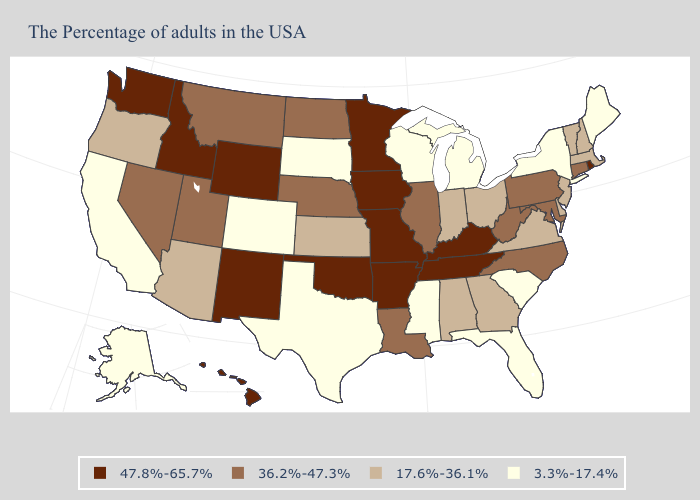Does Wisconsin have the lowest value in the USA?
Write a very short answer. Yes. What is the lowest value in states that border South Carolina?
Be succinct. 17.6%-36.1%. Which states hav the highest value in the Northeast?
Keep it brief. Rhode Island. Which states have the lowest value in the MidWest?
Be succinct. Michigan, Wisconsin, South Dakota. Does New York have the lowest value in the USA?
Short answer required. Yes. What is the lowest value in states that border Pennsylvania?
Short answer required. 3.3%-17.4%. Name the states that have a value in the range 47.8%-65.7%?
Answer briefly. Rhode Island, Kentucky, Tennessee, Missouri, Arkansas, Minnesota, Iowa, Oklahoma, Wyoming, New Mexico, Idaho, Washington, Hawaii. What is the value of Rhode Island?
Concise answer only. 47.8%-65.7%. What is the highest value in the West ?
Give a very brief answer. 47.8%-65.7%. Name the states that have a value in the range 3.3%-17.4%?
Be succinct. Maine, New York, South Carolina, Florida, Michigan, Wisconsin, Mississippi, Texas, South Dakota, Colorado, California, Alaska. What is the lowest value in the South?
Quick response, please. 3.3%-17.4%. Name the states that have a value in the range 3.3%-17.4%?
Short answer required. Maine, New York, South Carolina, Florida, Michigan, Wisconsin, Mississippi, Texas, South Dakota, Colorado, California, Alaska. Does Colorado have the lowest value in the West?
Answer briefly. Yes. What is the value of New Hampshire?
Keep it brief. 17.6%-36.1%. Among the states that border Mississippi , does Tennessee have the lowest value?
Write a very short answer. No. 